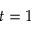Convert formula to latex. <formula><loc_0><loc_0><loc_500><loc_500>t = 1</formula> 